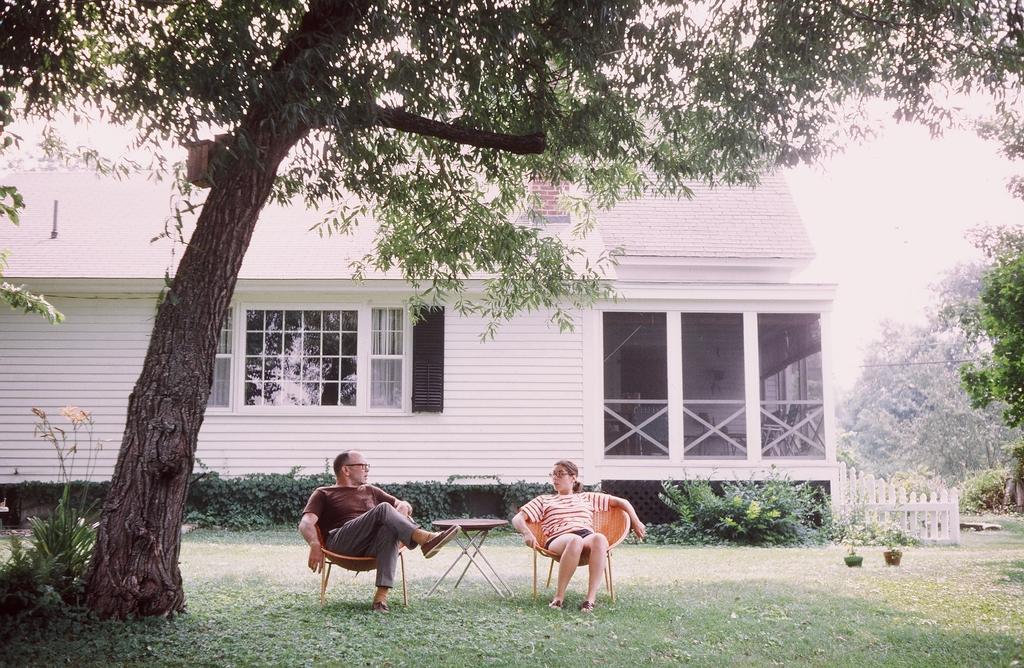How would you summarize this image in a sentence or two? In this picture, we can see two persons sitting on chairs, we can see the ground with grass, and some objects on the ground like chairs, table, plants in pot, house trees, plants, fencing, and the sky. 